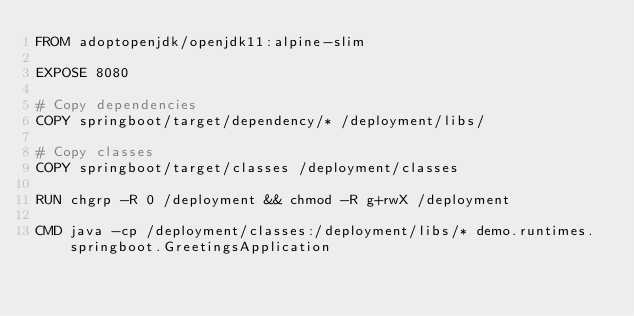Convert code to text. <code><loc_0><loc_0><loc_500><loc_500><_Dockerfile_>FROM adoptopenjdk/openjdk11:alpine-slim

EXPOSE 8080

# Copy dependencies
COPY springboot/target/dependency/* /deployment/libs/

# Copy classes
COPY springboot/target/classes /deployment/classes

RUN chgrp -R 0 /deployment && chmod -R g+rwX /deployment

CMD java -cp /deployment/classes:/deployment/libs/* demo.runtimes.springboot.GreetingsApplication
</code> 